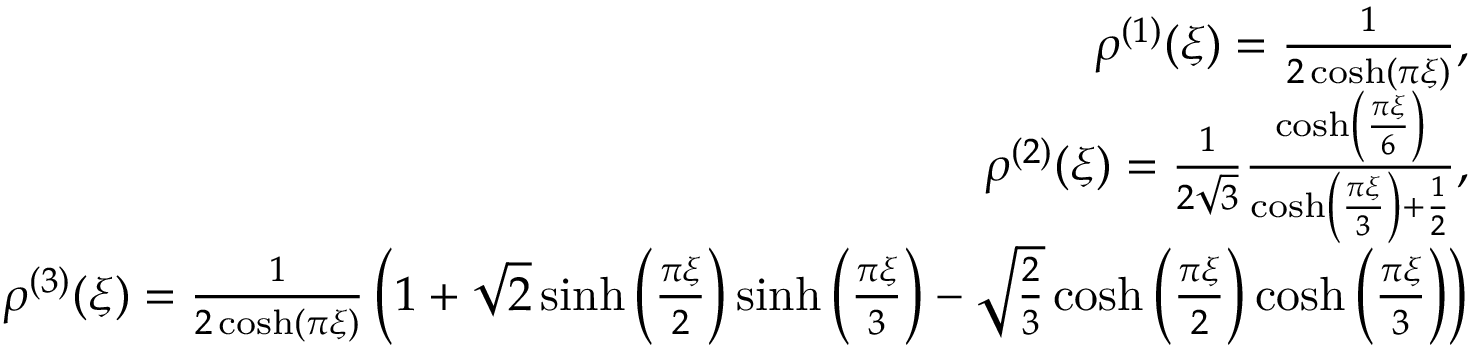<formula> <loc_0><loc_0><loc_500><loc_500>\begin{array} { r l r } & { \rho ^ { ( 1 ) } ( \xi ) = \frac { 1 } { 2 \cosh ( \pi \xi ) } , } \\ & { \rho ^ { ( 2 ) } ( \xi ) = \frac { 1 } { 2 \sqrt { 3 } } \frac { \cosh \left ( \frac { \pi \xi } { 6 } \right ) } { \cosh \left ( \frac { \pi \xi } { 3 } \right ) + \frac { 1 } { 2 } } , } \\ & { \rho ^ { ( 3 ) } ( \xi ) = \frac { 1 } { 2 \cosh ( \pi \xi ) } \left ( 1 + \sqrt { 2 } \sinh \left ( \frac { \pi \xi } { 2 } \right ) \sinh \left ( \frac { \pi \xi } { 3 } \right ) - \sqrt { \frac { 2 } { 3 } } \cosh \left ( \frac { \pi \xi } { 2 } \right ) \cosh \left ( \frac { \pi \xi } { 3 } \right ) \right ) } \end{array}</formula> 